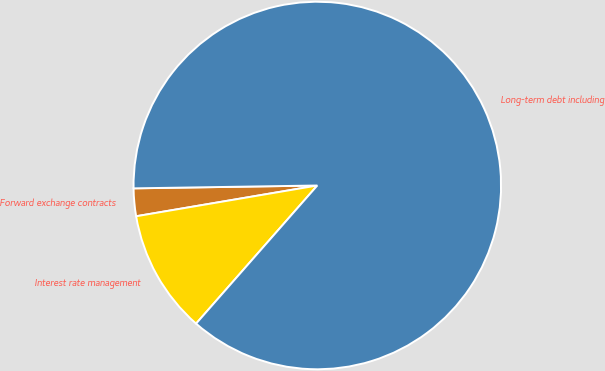Convert chart. <chart><loc_0><loc_0><loc_500><loc_500><pie_chart><fcel>Forward exchange contracts<fcel>Interest rate management<fcel>Long-term debt including<nl><fcel>2.43%<fcel>10.86%<fcel>86.72%<nl></chart> 